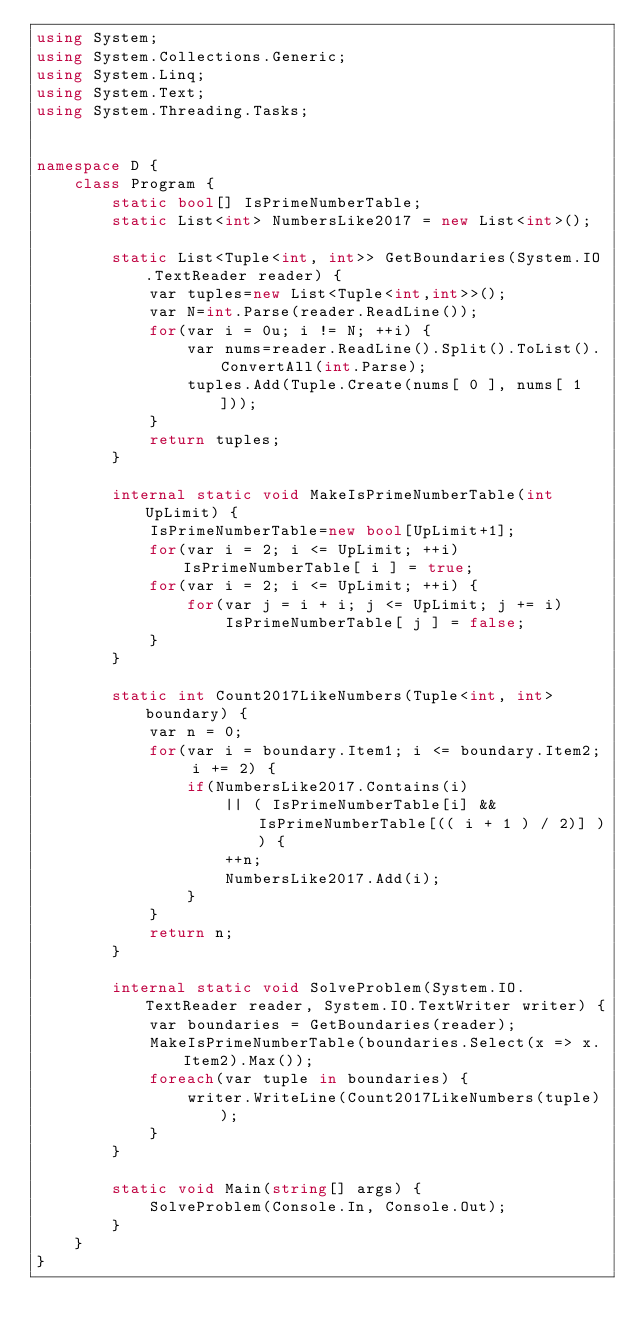<code> <loc_0><loc_0><loc_500><loc_500><_C#_>using System;
using System.Collections.Generic;
using System.Linq;
using System.Text;
using System.Threading.Tasks;


namespace D {
    class Program {
        static bool[] IsPrimeNumberTable;
        static List<int> NumbersLike2017 = new List<int>();

        static List<Tuple<int, int>> GetBoundaries(System.IO.TextReader reader) {
            var tuples=new List<Tuple<int,int>>();
            var N=int.Parse(reader.ReadLine());
            for(var i = 0u; i != N; ++i) {
                var nums=reader.ReadLine().Split().ToList().ConvertAll(int.Parse);
                tuples.Add(Tuple.Create(nums[ 0 ], nums[ 1 ]));
            }
            return tuples;
        }

        internal static void MakeIsPrimeNumberTable(int UpLimit) {
            IsPrimeNumberTable=new bool[UpLimit+1];
            for(var i = 2; i <= UpLimit; ++i) IsPrimeNumberTable[ i ] = true;
            for(var i = 2; i <= UpLimit; ++i) {
                for(var j = i + i; j <= UpLimit; j += i) 
                    IsPrimeNumberTable[ j ] = false;
            }
        }

        static int Count2017LikeNumbers(Tuple<int, int> boundary) {
            var n = 0;
            for(var i = boundary.Item1; i <= boundary.Item2; i += 2) {
                if(NumbersLike2017.Contains(i)
                    || ( IsPrimeNumberTable[i] && IsPrimeNumberTable[(( i + 1 ) / 2)] )) {
                    ++n;
                    NumbersLike2017.Add(i);
                }
            }
            return n;
        }

        internal static void SolveProblem(System.IO.TextReader reader, System.IO.TextWriter writer) {
            var boundaries = GetBoundaries(reader);
            MakeIsPrimeNumberTable(boundaries.Select(x => x.Item2).Max());
            foreach(var tuple in boundaries) {
                writer.WriteLine(Count2017LikeNumbers(tuple));
            }
        }

        static void Main(string[] args) {
            SolveProblem(Console.In, Console.Out);
        }
    }
}
</code> 